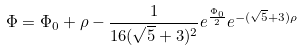<formula> <loc_0><loc_0><loc_500><loc_500>\Phi = \Phi _ { 0 } + \rho - \frac { 1 } { 1 6 ( \sqrt { 5 } + 3 ) ^ { 2 } } e ^ { \frac { \Phi _ { 0 } } { 2 } } e ^ { - ( \sqrt { 5 } + 3 ) \rho }</formula> 